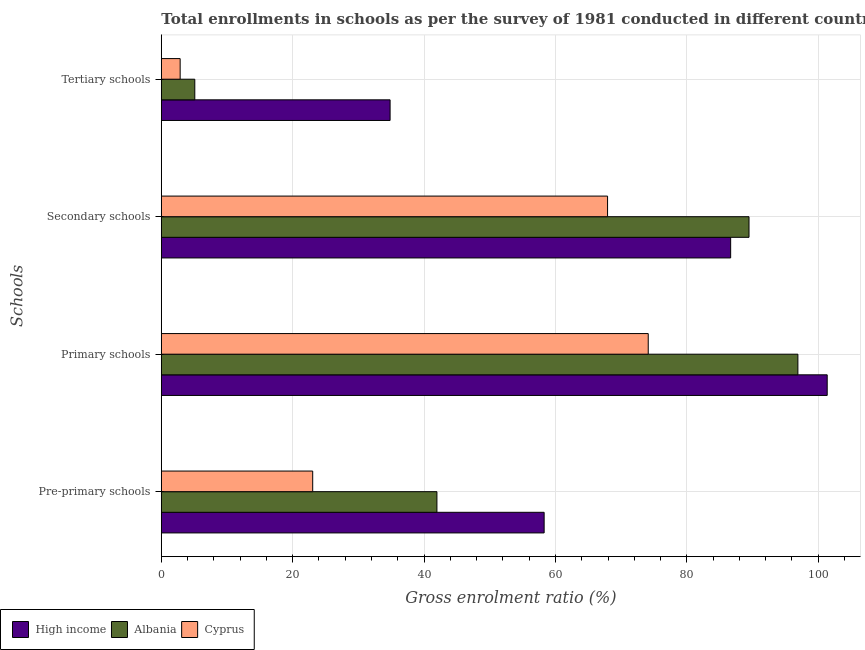How many different coloured bars are there?
Provide a succinct answer. 3. How many groups of bars are there?
Offer a very short reply. 4. Are the number of bars on each tick of the Y-axis equal?
Your answer should be compact. Yes. How many bars are there on the 2nd tick from the bottom?
Offer a terse response. 3. What is the label of the 2nd group of bars from the top?
Your answer should be very brief. Secondary schools. What is the gross enrolment ratio in secondary schools in High income?
Offer a very short reply. 86.67. Across all countries, what is the maximum gross enrolment ratio in secondary schools?
Provide a succinct answer. 89.47. Across all countries, what is the minimum gross enrolment ratio in primary schools?
Your answer should be compact. 74.13. In which country was the gross enrolment ratio in tertiary schools minimum?
Provide a succinct answer. Cyprus. What is the total gross enrolment ratio in pre-primary schools in the graph?
Offer a very short reply. 123.28. What is the difference between the gross enrolment ratio in primary schools in Cyprus and that in High income?
Provide a short and direct response. -27.24. What is the difference between the gross enrolment ratio in tertiary schools in Albania and the gross enrolment ratio in secondary schools in Cyprus?
Offer a terse response. -62.84. What is the average gross enrolment ratio in pre-primary schools per country?
Offer a very short reply. 41.09. What is the difference between the gross enrolment ratio in primary schools and gross enrolment ratio in tertiary schools in Albania?
Ensure brevity in your answer.  91.81. In how many countries, is the gross enrolment ratio in tertiary schools greater than 52 %?
Your response must be concise. 0. What is the ratio of the gross enrolment ratio in primary schools in High income to that in Cyprus?
Your response must be concise. 1.37. Is the gross enrolment ratio in primary schools in High income less than that in Cyprus?
Keep it short and to the point. No. Is the difference between the gross enrolment ratio in pre-primary schools in Albania and High income greater than the difference between the gross enrolment ratio in primary schools in Albania and High income?
Ensure brevity in your answer.  No. What is the difference between the highest and the second highest gross enrolment ratio in tertiary schools?
Provide a succinct answer. 29.73. What is the difference between the highest and the lowest gross enrolment ratio in primary schools?
Your answer should be compact. 27.24. In how many countries, is the gross enrolment ratio in tertiary schools greater than the average gross enrolment ratio in tertiary schools taken over all countries?
Offer a very short reply. 1. Is the sum of the gross enrolment ratio in pre-primary schools in Cyprus and High income greater than the maximum gross enrolment ratio in secondary schools across all countries?
Give a very brief answer. No. Is it the case that in every country, the sum of the gross enrolment ratio in primary schools and gross enrolment ratio in tertiary schools is greater than the sum of gross enrolment ratio in pre-primary schools and gross enrolment ratio in secondary schools?
Your answer should be compact. No. What does the 2nd bar from the top in Primary schools represents?
Offer a terse response. Albania. What does the 2nd bar from the bottom in Primary schools represents?
Offer a very short reply. Albania. Are all the bars in the graph horizontal?
Ensure brevity in your answer.  Yes. Are the values on the major ticks of X-axis written in scientific E-notation?
Keep it short and to the point. No. Does the graph contain any zero values?
Offer a very short reply. No. Does the graph contain grids?
Your response must be concise. Yes. Where does the legend appear in the graph?
Provide a succinct answer. Bottom left. How many legend labels are there?
Ensure brevity in your answer.  3. How are the legend labels stacked?
Give a very brief answer. Horizontal. What is the title of the graph?
Your answer should be compact. Total enrollments in schools as per the survey of 1981 conducted in different countries. Does "OECD members" appear as one of the legend labels in the graph?
Offer a very short reply. No. What is the label or title of the X-axis?
Your answer should be compact. Gross enrolment ratio (%). What is the label or title of the Y-axis?
Your answer should be compact. Schools. What is the Gross enrolment ratio (%) in High income in Pre-primary schools?
Your response must be concise. 58.28. What is the Gross enrolment ratio (%) of Albania in Pre-primary schools?
Make the answer very short. 41.96. What is the Gross enrolment ratio (%) of Cyprus in Pre-primary schools?
Give a very brief answer. 23.05. What is the Gross enrolment ratio (%) of High income in Primary schools?
Give a very brief answer. 101.37. What is the Gross enrolment ratio (%) in Albania in Primary schools?
Provide a succinct answer. 96.91. What is the Gross enrolment ratio (%) in Cyprus in Primary schools?
Make the answer very short. 74.13. What is the Gross enrolment ratio (%) of High income in Secondary schools?
Your answer should be compact. 86.67. What is the Gross enrolment ratio (%) of Albania in Secondary schools?
Provide a short and direct response. 89.47. What is the Gross enrolment ratio (%) in Cyprus in Secondary schools?
Make the answer very short. 67.93. What is the Gross enrolment ratio (%) of High income in Tertiary schools?
Offer a terse response. 34.83. What is the Gross enrolment ratio (%) of Albania in Tertiary schools?
Your answer should be compact. 5.1. What is the Gross enrolment ratio (%) of Cyprus in Tertiary schools?
Offer a terse response. 2.87. Across all Schools, what is the maximum Gross enrolment ratio (%) in High income?
Make the answer very short. 101.37. Across all Schools, what is the maximum Gross enrolment ratio (%) in Albania?
Ensure brevity in your answer.  96.91. Across all Schools, what is the maximum Gross enrolment ratio (%) of Cyprus?
Your answer should be compact. 74.13. Across all Schools, what is the minimum Gross enrolment ratio (%) of High income?
Your answer should be very brief. 34.83. Across all Schools, what is the minimum Gross enrolment ratio (%) of Albania?
Your response must be concise. 5.1. Across all Schools, what is the minimum Gross enrolment ratio (%) in Cyprus?
Provide a succinct answer. 2.87. What is the total Gross enrolment ratio (%) in High income in the graph?
Provide a succinct answer. 281.15. What is the total Gross enrolment ratio (%) of Albania in the graph?
Your answer should be compact. 233.43. What is the total Gross enrolment ratio (%) in Cyprus in the graph?
Make the answer very short. 167.97. What is the difference between the Gross enrolment ratio (%) of High income in Pre-primary schools and that in Primary schools?
Keep it short and to the point. -43.09. What is the difference between the Gross enrolment ratio (%) of Albania in Pre-primary schools and that in Primary schools?
Provide a short and direct response. -54.95. What is the difference between the Gross enrolment ratio (%) in Cyprus in Pre-primary schools and that in Primary schools?
Your answer should be very brief. -51.08. What is the difference between the Gross enrolment ratio (%) in High income in Pre-primary schools and that in Secondary schools?
Provide a succinct answer. -28.39. What is the difference between the Gross enrolment ratio (%) of Albania in Pre-primary schools and that in Secondary schools?
Offer a very short reply. -47.51. What is the difference between the Gross enrolment ratio (%) of Cyprus in Pre-primary schools and that in Secondary schools?
Ensure brevity in your answer.  -44.89. What is the difference between the Gross enrolment ratio (%) of High income in Pre-primary schools and that in Tertiary schools?
Your answer should be very brief. 23.45. What is the difference between the Gross enrolment ratio (%) in Albania in Pre-primary schools and that in Tertiary schools?
Offer a terse response. 36.86. What is the difference between the Gross enrolment ratio (%) of Cyprus in Pre-primary schools and that in Tertiary schools?
Offer a very short reply. 20.18. What is the difference between the Gross enrolment ratio (%) in High income in Primary schools and that in Secondary schools?
Your answer should be very brief. 14.7. What is the difference between the Gross enrolment ratio (%) in Albania in Primary schools and that in Secondary schools?
Keep it short and to the point. 7.44. What is the difference between the Gross enrolment ratio (%) of Cyprus in Primary schools and that in Secondary schools?
Provide a short and direct response. 6.19. What is the difference between the Gross enrolment ratio (%) in High income in Primary schools and that in Tertiary schools?
Provide a succinct answer. 66.54. What is the difference between the Gross enrolment ratio (%) of Albania in Primary schools and that in Tertiary schools?
Your answer should be compact. 91.81. What is the difference between the Gross enrolment ratio (%) of Cyprus in Primary schools and that in Tertiary schools?
Make the answer very short. 71.26. What is the difference between the Gross enrolment ratio (%) of High income in Secondary schools and that in Tertiary schools?
Provide a short and direct response. 51.85. What is the difference between the Gross enrolment ratio (%) of Albania in Secondary schools and that in Tertiary schools?
Offer a very short reply. 84.37. What is the difference between the Gross enrolment ratio (%) of Cyprus in Secondary schools and that in Tertiary schools?
Make the answer very short. 65.07. What is the difference between the Gross enrolment ratio (%) of High income in Pre-primary schools and the Gross enrolment ratio (%) of Albania in Primary schools?
Keep it short and to the point. -38.63. What is the difference between the Gross enrolment ratio (%) of High income in Pre-primary schools and the Gross enrolment ratio (%) of Cyprus in Primary schools?
Your answer should be very brief. -15.85. What is the difference between the Gross enrolment ratio (%) in Albania in Pre-primary schools and the Gross enrolment ratio (%) in Cyprus in Primary schools?
Give a very brief answer. -32.17. What is the difference between the Gross enrolment ratio (%) in High income in Pre-primary schools and the Gross enrolment ratio (%) in Albania in Secondary schools?
Make the answer very short. -31.19. What is the difference between the Gross enrolment ratio (%) of High income in Pre-primary schools and the Gross enrolment ratio (%) of Cyprus in Secondary schools?
Your answer should be compact. -9.66. What is the difference between the Gross enrolment ratio (%) of Albania in Pre-primary schools and the Gross enrolment ratio (%) of Cyprus in Secondary schools?
Give a very brief answer. -25.98. What is the difference between the Gross enrolment ratio (%) in High income in Pre-primary schools and the Gross enrolment ratio (%) in Albania in Tertiary schools?
Your response must be concise. 53.18. What is the difference between the Gross enrolment ratio (%) in High income in Pre-primary schools and the Gross enrolment ratio (%) in Cyprus in Tertiary schools?
Provide a succinct answer. 55.41. What is the difference between the Gross enrolment ratio (%) of Albania in Pre-primary schools and the Gross enrolment ratio (%) of Cyprus in Tertiary schools?
Your answer should be very brief. 39.09. What is the difference between the Gross enrolment ratio (%) of High income in Primary schools and the Gross enrolment ratio (%) of Albania in Secondary schools?
Make the answer very short. 11.9. What is the difference between the Gross enrolment ratio (%) in High income in Primary schools and the Gross enrolment ratio (%) in Cyprus in Secondary schools?
Your answer should be very brief. 33.43. What is the difference between the Gross enrolment ratio (%) in Albania in Primary schools and the Gross enrolment ratio (%) in Cyprus in Secondary schools?
Your answer should be very brief. 28.97. What is the difference between the Gross enrolment ratio (%) in High income in Primary schools and the Gross enrolment ratio (%) in Albania in Tertiary schools?
Keep it short and to the point. 96.27. What is the difference between the Gross enrolment ratio (%) in High income in Primary schools and the Gross enrolment ratio (%) in Cyprus in Tertiary schools?
Give a very brief answer. 98.5. What is the difference between the Gross enrolment ratio (%) in Albania in Primary schools and the Gross enrolment ratio (%) in Cyprus in Tertiary schools?
Offer a very short reply. 94.04. What is the difference between the Gross enrolment ratio (%) in High income in Secondary schools and the Gross enrolment ratio (%) in Albania in Tertiary schools?
Offer a very short reply. 81.58. What is the difference between the Gross enrolment ratio (%) in High income in Secondary schools and the Gross enrolment ratio (%) in Cyprus in Tertiary schools?
Your response must be concise. 83.8. What is the difference between the Gross enrolment ratio (%) of Albania in Secondary schools and the Gross enrolment ratio (%) of Cyprus in Tertiary schools?
Offer a terse response. 86.6. What is the average Gross enrolment ratio (%) in High income per Schools?
Your response must be concise. 70.29. What is the average Gross enrolment ratio (%) in Albania per Schools?
Your answer should be very brief. 58.36. What is the average Gross enrolment ratio (%) of Cyprus per Schools?
Provide a succinct answer. 41.99. What is the difference between the Gross enrolment ratio (%) in High income and Gross enrolment ratio (%) in Albania in Pre-primary schools?
Your response must be concise. 16.32. What is the difference between the Gross enrolment ratio (%) of High income and Gross enrolment ratio (%) of Cyprus in Pre-primary schools?
Keep it short and to the point. 35.23. What is the difference between the Gross enrolment ratio (%) of Albania and Gross enrolment ratio (%) of Cyprus in Pre-primary schools?
Your response must be concise. 18.91. What is the difference between the Gross enrolment ratio (%) in High income and Gross enrolment ratio (%) in Albania in Primary schools?
Keep it short and to the point. 4.46. What is the difference between the Gross enrolment ratio (%) in High income and Gross enrolment ratio (%) in Cyprus in Primary schools?
Give a very brief answer. 27.24. What is the difference between the Gross enrolment ratio (%) in Albania and Gross enrolment ratio (%) in Cyprus in Primary schools?
Your answer should be compact. 22.78. What is the difference between the Gross enrolment ratio (%) in High income and Gross enrolment ratio (%) in Albania in Secondary schools?
Provide a short and direct response. -2.79. What is the difference between the Gross enrolment ratio (%) in High income and Gross enrolment ratio (%) in Cyprus in Secondary schools?
Provide a succinct answer. 18.74. What is the difference between the Gross enrolment ratio (%) in Albania and Gross enrolment ratio (%) in Cyprus in Secondary schools?
Give a very brief answer. 21.53. What is the difference between the Gross enrolment ratio (%) of High income and Gross enrolment ratio (%) of Albania in Tertiary schools?
Your answer should be compact. 29.73. What is the difference between the Gross enrolment ratio (%) in High income and Gross enrolment ratio (%) in Cyprus in Tertiary schools?
Your answer should be very brief. 31.96. What is the difference between the Gross enrolment ratio (%) of Albania and Gross enrolment ratio (%) of Cyprus in Tertiary schools?
Offer a terse response. 2.23. What is the ratio of the Gross enrolment ratio (%) in High income in Pre-primary schools to that in Primary schools?
Offer a very short reply. 0.57. What is the ratio of the Gross enrolment ratio (%) of Albania in Pre-primary schools to that in Primary schools?
Make the answer very short. 0.43. What is the ratio of the Gross enrolment ratio (%) of Cyprus in Pre-primary schools to that in Primary schools?
Ensure brevity in your answer.  0.31. What is the ratio of the Gross enrolment ratio (%) of High income in Pre-primary schools to that in Secondary schools?
Keep it short and to the point. 0.67. What is the ratio of the Gross enrolment ratio (%) of Albania in Pre-primary schools to that in Secondary schools?
Make the answer very short. 0.47. What is the ratio of the Gross enrolment ratio (%) in Cyprus in Pre-primary schools to that in Secondary schools?
Your answer should be compact. 0.34. What is the ratio of the Gross enrolment ratio (%) of High income in Pre-primary schools to that in Tertiary schools?
Make the answer very short. 1.67. What is the ratio of the Gross enrolment ratio (%) of Albania in Pre-primary schools to that in Tertiary schools?
Offer a very short reply. 8.23. What is the ratio of the Gross enrolment ratio (%) of Cyprus in Pre-primary schools to that in Tertiary schools?
Your answer should be very brief. 8.03. What is the ratio of the Gross enrolment ratio (%) of High income in Primary schools to that in Secondary schools?
Make the answer very short. 1.17. What is the ratio of the Gross enrolment ratio (%) of Albania in Primary schools to that in Secondary schools?
Make the answer very short. 1.08. What is the ratio of the Gross enrolment ratio (%) in Cyprus in Primary schools to that in Secondary schools?
Ensure brevity in your answer.  1.09. What is the ratio of the Gross enrolment ratio (%) in High income in Primary schools to that in Tertiary schools?
Keep it short and to the point. 2.91. What is the ratio of the Gross enrolment ratio (%) in Albania in Primary schools to that in Tertiary schools?
Keep it short and to the point. 19.02. What is the ratio of the Gross enrolment ratio (%) in Cyprus in Primary schools to that in Tertiary schools?
Provide a succinct answer. 25.84. What is the ratio of the Gross enrolment ratio (%) of High income in Secondary schools to that in Tertiary schools?
Give a very brief answer. 2.49. What is the ratio of the Gross enrolment ratio (%) in Albania in Secondary schools to that in Tertiary schools?
Provide a succinct answer. 17.56. What is the ratio of the Gross enrolment ratio (%) in Cyprus in Secondary schools to that in Tertiary schools?
Keep it short and to the point. 23.68. What is the difference between the highest and the second highest Gross enrolment ratio (%) of High income?
Ensure brevity in your answer.  14.7. What is the difference between the highest and the second highest Gross enrolment ratio (%) of Albania?
Give a very brief answer. 7.44. What is the difference between the highest and the second highest Gross enrolment ratio (%) in Cyprus?
Provide a succinct answer. 6.19. What is the difference between the highest and the lowest Gross enrolment ratio (%) of High income?
Offer a very short reply. 66.54. What is the difference between the highest and the lowest Gross enrolment ratio (%) in Albania?
Your answer should be compact. 91.81. What is the difference between the highest and the lowest Gross enrolment ratio (%) in Cyprus?
Provide a short and direct response. 71.26. 